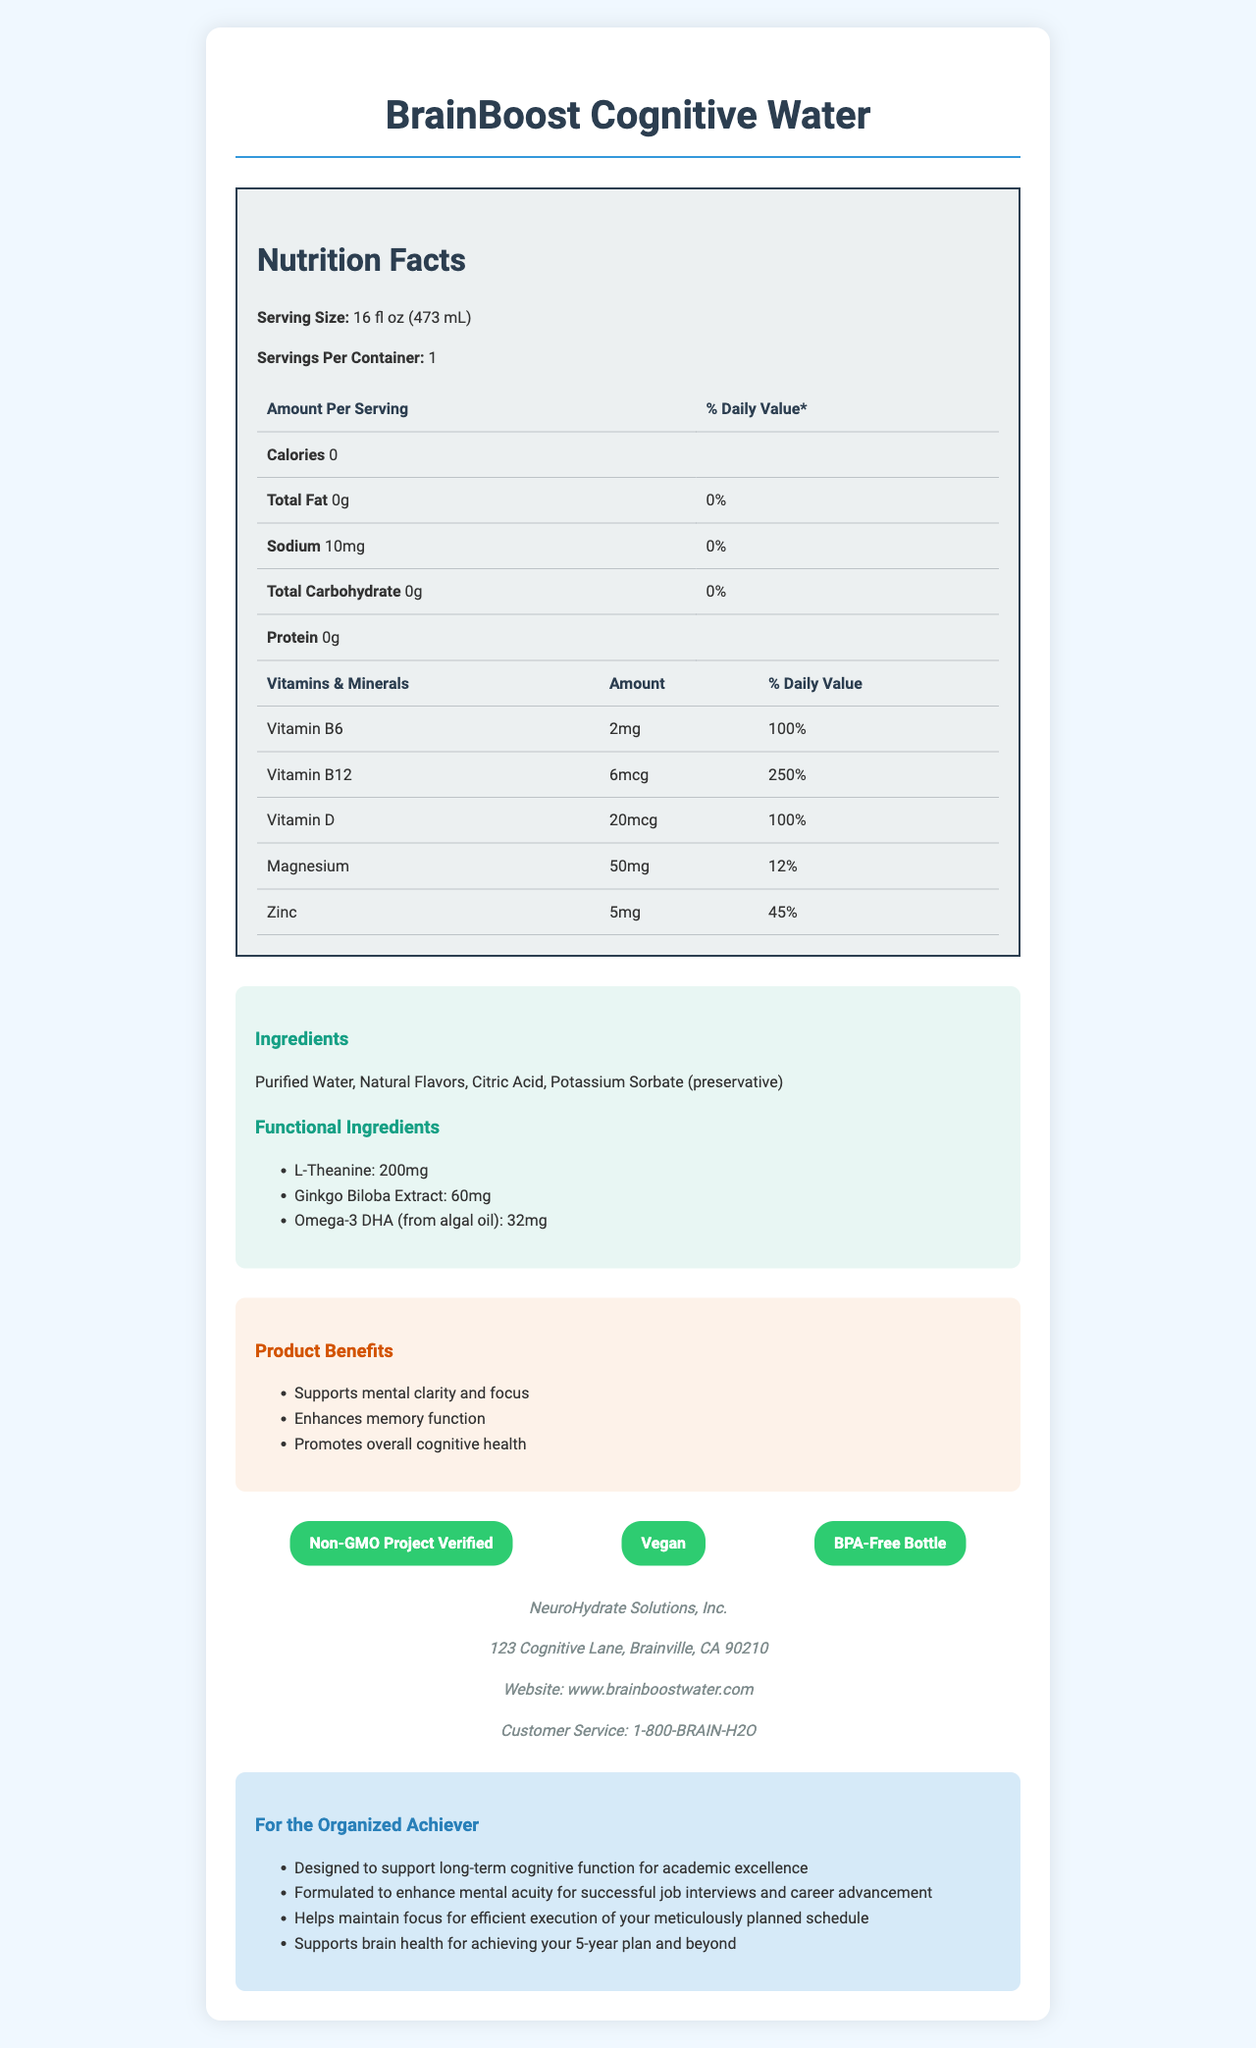how many calories are in one serving of BrainBoost Cognitive Water? The document specifies that the product contains 0 calories per serving.
Answer: 0 calories what is the serving size of BrainBoost Cognitive Water? The document lists the serving size as 16 fl oz (473 mL).
Answer: 16 fl oz (473 mL) which vitamins are present in BrainBoost Cognitive Water? According to the document, the vitamins included are Vitamin B6, Vitamin B12, and Vitamin D.
Answer: Vitamin B6, Vitamin B12, Vitamin D how much magnesium does one serving contain? The document indicates that one serving contains 50mg of magnesium.
Answer: 50mg what are the main product benefits of BrainBoost Cognitive Water? The document outlines that the product benefits include supporting mental clarity and focus, enhancing memory function, and promoting overall cognitive health.
Answer: Supports mental clarity and focus, Enhances memory function, Promotes overall cognitive health which of the following certifications does BrainBoost Cognitive Water have? 
A. Gluten-Free
B. Non-GMO Project Verified
C. USDA Organic
D. Kosher The document indicates that BrainBoost Cognitive Water is Non-GMO Project Verified.
Answer: B what is the recommended usage of BrainBoost Cognitive Water? 
A. Consume with meals
B. Drink as needed throughout the day
C. Consume 1 bottle daily as part of your morning routine
D. Drink before bedtime The document recommends consuming 1 bottle daily as part of your morning routine for optimal cognitive support.
Answer: C contains BrainBoost Cognitive Water any allergens? The document explicitly states that the product contains no known allergens.
Answer: Contains no known allergens does BrainBoost Cognitive Water contain sugar? The document lists total carbohydrates as 0g, which implies that there is no sugar in the product.
Answer: No describe the information provided by the document The description encapsulates the various sections of the document, such as nutritional facts, vitamins and minerals, ingredients, benefits, certifications, and target audience information. It covers the key points to help understand the main idea of the product's features and intended use.
Answer: The document offers an overview of BrainBoost Cognitive Water, detailing its ingredients, nutritional information, product benefits, certifications, company info, and usage recommendations. It emphasizes the product's cognitive support functions and its alignment with health-conscious and organized individuals, highlighting its Non-GMO Project Verified and vegan certifications. The document also includes storage instructions and states that the product supports academic performance, career preparation, time management, and long-term brain health. how long does BrainBoost Cognitive Water last after opening? The document specifies to consume the product within 7 days after opening.
Answer: 7 days how does BrainBoost Cognitive Water support career preparation? The document states that the product is formulated to enhance mental acuity for successful job interviews and career advancement.
Answer: Enhances mental acuity for successful job interviews and career advancement what is the amount of L-Theanine in the product? The document mentions that the product contains 200mg of L-Theanine per serving.
Answer: 200mg what company manufactures BrainBoost Cognitive Water? The document lists NeuroHydrate Solutions, Inc. as the manufacturer.
Answer: NeuroHydrate Solutions, Inc. is BrainBoost Cognitive Water certified as BPA-Free? The document includes BPA-Free Bottle as one of its certifications.
Answer: Yes does BrainBoost Cognitive Water help with exercise performance? The document does not provide any information or mention any benefits related to exercise performance.
Answer: Cannot be determined 